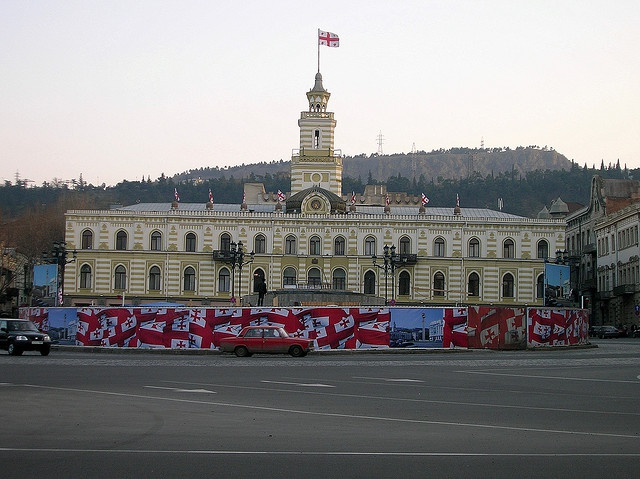Describe the objects in this image and their specific colors. I can see car in lavender, black, maroon, gray, and darkgray tones, car in lavender, black, gray, and blue tones, car in lavender, black, gray, and purple tones, people in lavender, black, and gray tones, and car in lavender, black, and purple tones in this image. 